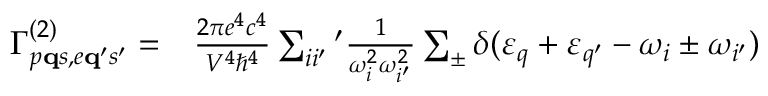<formula> <loc_0><loc_0><loc_500><loc_500>\begin{array} { r l } { \Gamma _ { p { q } s , e { q } ^ { \prime } s ^ { \prime } } ^ { ( 2 ) } = } & \frac { 2 \pi e ^ { 4 } c ^ { 4 } } { V ^ { 4 } \hbar { ^ } { 4 } } \sum _ { i i ^ { \prime } ^ { \prime } \frac { 1 } { \omega _ { i } ^ { 2 } \omega _ { i ^ { \prime } } ^ { 2 } } \sum _ { \pm } \delta ( \varepsilon _ { q } + \varepsilon _ { q ^ { \prime } } - \omega _ { i } \pm \omega _ { i ^ { \prime } } ) } \end{array}</formula> 